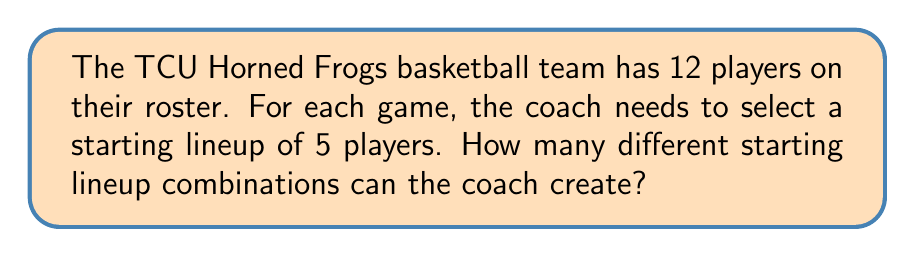Teach me how to tackle this problem. Let's approach this step-by-step:

1) This is a problem of combinations, not permutations. We're selecting 5 players from a group of 12, and the order of selection doesn't matter (i.e., selecting players A, B, C, D, E is the same lineup as B, A, E, C, D).

2) The formula for combinations is:

   $$C(n,r) = \frac{n!}{r!(n-r)!}$$

   where $n$ is the total number of items to choose from, and $r$ is the number of items being chosen.

3) In this case, $n = 12$ (total players) and $r = 5$ (players in the starting lineup).

4) Plugging these numbers into our formula:

   $$C(12,5) = \frac{12!}{5!(12-5)!} = \frac{12!}{5!(7)!}$$

5) Expanding this:
   
   $$\frac{12 * 11 * 10 * 9 * 8 * 7!}{(5 * 4 * 3 * 2 * 1) * 7!}$$

6) The 7! cancels out in the numerator and denominator:

   $$\frac{12 * 11 * 10 * 9 * 8}{5 * 4 * 3 * 2 * 1}$$

7) Multiplying the numerator and denominator:

   $$\frac{95,040}{120} = 792$$

Therefore, the coach can create 792 different starting lineup combinations.
Answer: 792 different starting lineup combinations 